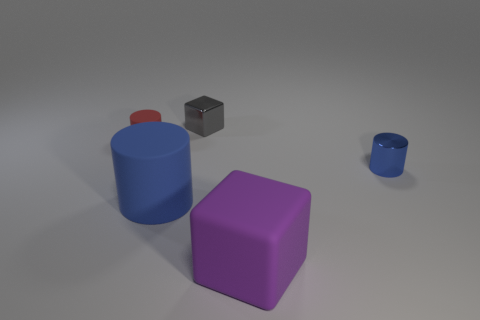How many other metal cubes have the same color as the shiny block?
Your response must be concise. 0. The tiny red object is what shape?
Your answer should be very brief. Cylinder. There is a cylinder that is behind the big blue object and in front of the small rubber thing; what color is it?
Your response must be concise. Blue. What is the tiny blue cylinder made of?
Keep it short and to the point. Metal. There is a blue object that is to the left of the small blue metal object; what shape is it?
Ensure brevity in your answer.  Cylinder. What is the color of the rubber cylinder that is the same size as the gray shiny cube?
Your answer should be very brief. Red. Do the big object that is on the right side of the shiny block and the large blue cylinder have the same material?
Keep it short and to the point. Yes. There is a object that is in front of the metal cylinder and behind the purple object; what is its size?
Offer a very short reply. Large. How big is the cylinder right of the tiny gray shiny block?
Your answer should be compact. Small. The metal thing that is the same color as the big matte cylinder is what shape?
Your response must be concise. Cylinder. 